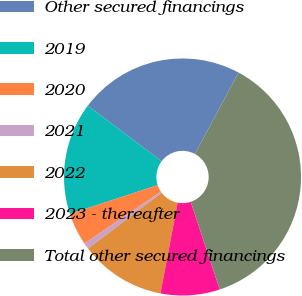<chart> <loc_0><loc_0><loc_500><loc_500><pie_chart><fcel>Other secured financings<fcel>2019<fcel>2020<fcel>2021<fcel>2022<fcel>2023 - thereafter<fcel>Total other secured financings<nl><fcel>22.57%<fcel>15.32%<fcel>4.45%<fcel>0.82%<fcel>11.7%<fcel>8.07%<fcel>37.07%<nl></chart> 